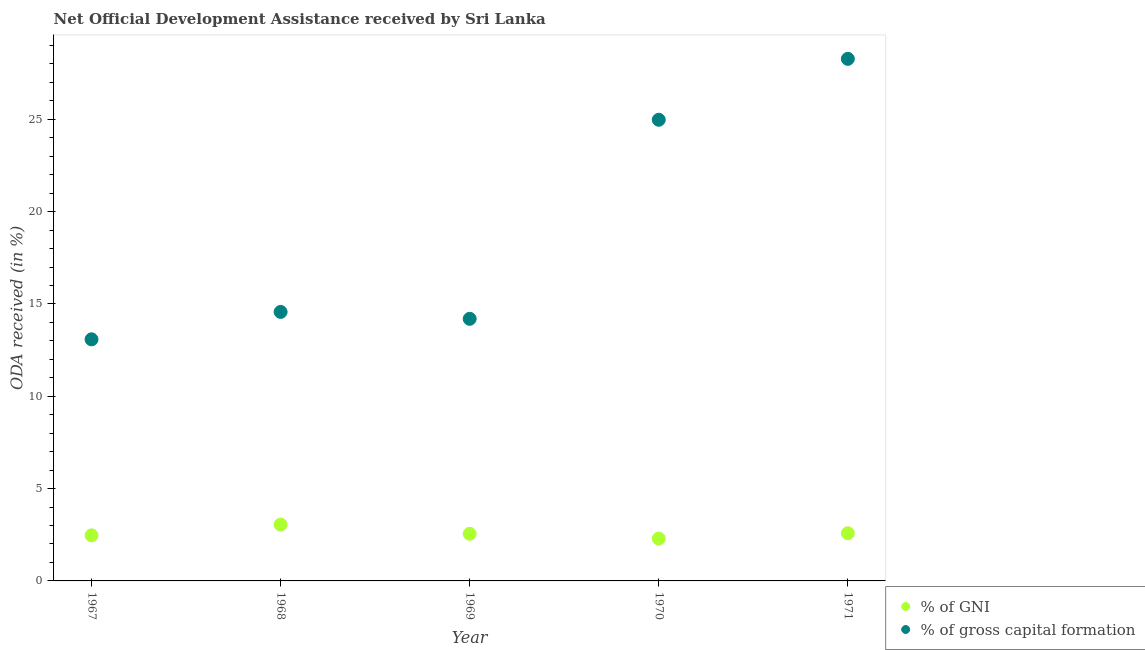How many different coloured dotlines are there?
Provide a succinct answer. 2. What is the oda received as percentage of gni in 1967?
Your answer should be compact. 2.47. Across all years, what is the maximum oda received as percentage of gross capital formation?
Provide a short and direct response. 28.28. Across all years, what is the minimum oda received as percentage of gni?
Give a very brief answer. 2.29. In which year was the oda received as percentage of gross capital formation maximum?
Provide a succinct answer. 1971. In which year was the oda received as percentage of gni minimum?
Provide a short and direct response. 1970. What is the total oda received as percentage of gni in the graph?
Offer a terse response. 12.95. What is the difference between the oda received as percentage of gni in 1968 and that in 1969?
Keep it short and to the point. 0.5. What is the difference between the oda received as percentage of gni in 1967 and the oda received as percentage of gross capital formation in 1971?
Give a very brief answer. -25.81. What is the average oda received as percentage of gni per year?
Make the answer very short. 2.59. In the year 1970, what is the difference between the oda received as percentage of gni and oda received as percentage of gross capital formation?
Keep it short and to the point. -22.68. What is the ratio of the oda received as percentage of gni in 1969 to that in 1970?
Provide a short and direct response. 1.11. Is the oda received as percentage of gross capital formation in 1967 less than that in 1969?
Ensure brevity in your answer.  Yes. What is the difference between the highest and the second highest oda received as percentage of gross capital formation?
Provide a short and direct response. 3.3. What is the difference between the highest and the lowest oda received as percentage of gni?
Your answer should be compact. 0.76. In how many years, is the oda received as percentage of gni greater than the average oda received as percentage of gni taken over all years?
Your answer should be very brief. 1. Is the sum of the oda received as percentage of gni in 1968 and 1971 greater than the maximum oda received as percentage of gross capital formation across all years?
Provide a succinct answer. No. Does the oda received as percentage of gni monotonically increase over the years?
Your answer should be very brief. No. Is the oda received as percentage of gross capital formation strictly greater than the oda received as percentage of gni over the years?
Your response must be concise. Yes. How many years are there in the graph?
Offer a terse response. 5. What is the difference between two consecutive major ticks on the Y-axis?
Offer a very short reply. 5. Are the values on the major ticks of Y-axis written in scientific E-notation?
Your answer should be very brief. No. How are the legend labels stacked?
Make the answer very short. Vertical. What is the title of the graph?
Ensure brevity in your answer.  Net Official Development Assistance received by Sri Lanka. What is the label or title of the Y-axis?
Offer a terse response. ODA received (in %). What is the ODA received (in %) of % of GNI in 1967?
Provide a short and direct response. 2.47. What is the ODA received (in %) of % of gross capital formation in 1967?
Ensure brevity in your answer.  13.09. What is the ODA received (in %) of % of GNI in 1968?
Make the answer very short. 3.05. What is the ODA received (in %) in % of gross capital formation in 1968?
Offer a very short reply. 14.57. What is the ODA received (in %) of % of GNI in 1969?
Give a very brief answer. 2.55. What is the ODA received (in %) in % of gross capital formation in 1969?
Make the answer very short. 14.2. What is the ODA received (in %) in % of GNI in 1970?
Give a very brief answer. 2.29. What is the ODA received (in %) of % of gross capital formation in 1970?
Offer a very short reply. 24.98. What is the ODA received (in %) of % of GNI in 1971?
Offer a terse response. 2.58. What is the ODA received (in %) of % of gross capital formation in 1971?
Your response must be concise. 28.28. Across all years, what is the maximum ODA received (in %) in % of GNI?
Offer a terse response. 3.05. Across all years, what is the maximum ODA received (in %) in % of gross capital formation?
Ensure brevity in your answer.  28.28. Across all years, what is the minimum ODA received (in %) in % of GNI?
Provide a short and direct response. 2.29. Across all years, what is the minimum ODA received (in %) in % of gross capital formation?
Give a very brief answer. 13.09. What is the total ODA received (in %) in % of GNI in the graph?
Your response must be concise. 12.95. What is the total ODA received (in %) in % of gross capital formation in the graph?
Provide a succinct answer. 95.1. What is the difference between the ODA received (in %) in % of GNI in 1967 and that in 1968?
Your answer should be compact. -0.58. What is the difference between the ODA received (in %) of % of gross capital formation in 1967 and that in 1968?
Give a very brief answer. -1.48. What is the difference between the ODA received (in %) in % of GNI in 1967 and that in 1969?
Provide a short and direct response. -0.08. What is the difference between the ODA received (in %) of % of gross capital formation in 1967 and that in 1969?
Ensure brevity in your answer.  -1.11. What is the difference between the ODA received (in %) in % of GNI in 1967 and that in 1970?
Your answer should be very brief. 0.17. What is the difference between the ODA received (in %) of % of gross capital formation in 1967 and that in 1970?
Keep it short and to the point. -11.89. What is the difference between the ODA received (in %) of % of GNI in 1967 and that in 1971?
Provide a short and direct response. -0.11. What is the difference between the ODA received (in %) in % of gross capital formation in 1967 and that in 1971?
Offer a terse response. -15.19. What is the difference between the ODA received (in %) in % of GNI in 1968 and that in 1969?
Provide a short and direct response. 0.5. What is the difference between the ODA received (in %) in % of gross capital formation in 1968 and that in 1969?
Your answer should be compact. 0.37. What is the difference between the ODA received (in %) in % of GNI in 1968 and that in 1970?
Make the answer very short. 0.76. What is the difference between the ODA received (in %) in % of gross capital formation in 1968 and that in 1970?
Your answer should be very brief. -10.41. What is the difference between the ODA received (in %) in % of GNI in 1968 and that in 1971?
Offer a very short reply. 0.47. What is the difference between the ODA received (in %) in % of gross capital formation in 1968 and that in 1971?
Keep it short and to the point. -13.71. What is the difference between the ODA received (in %) of % of GNI in 1969 and that in 1970?
Ensure brevity in your answer.  0.26. What is the difference between the ODA received (in %) in % of gross capital formation in 1969 and that in 1970?
Offer a very short reply. -10.78. What is the difference between the ODA received (in %) of % of GNI in 1969 and that in 1971?
Your answer should be compact. -0.03. What is the difference between the ODA received (in %) of % of gross capital formation in 1969 and that in 1971?
Offer a very short reply. -14.08. What is the difference between the ODA received (in %) of % of GNI in 1970 and that in 1971?
Your answer should be compact. -0.29. What is the difference between the ODA received (in %) of % of gross capital formation in 1970 and that in 1971?
Your response must be concise. -3.3. What is the difference between the ODA received (in %) of % of GNI in 1967 and the ODA received (in %) of % of gross capital formation in 1968?
Keep it short and to the point. -12.1. What is the difference between the ODA received (in %) in % of GNI in 1967 and the ODA received (in %) in % of gross capital formation in 1969?
Provide a short and direct response. -11.73. What is the difference between the ODA received (in %) in % of GNI in 1967 and the ODA received (in %) in % of gross capital formation in 1970?
Ensure brevity in your answer.  -22.51. What is the difference between the ODA received (in %) of % of GNI in 1967 and the ODA received (in %) of % of gross capital formation in 1971?
Give a very brief answer. -25.81. What is the difference between the ODA received (in %) of % of GNI in 1968 and the ODA received (in %) of % of gross capital formation in 1969?
Make the answer very short. -11.15. What is the difference between the ODA received (in %) in % of GNI in 1968 and the ODA received (in %) in % of gross capital formation in 1970?
Offer a terse response. -21.93. What is the difference between the ODA received (in %) of % of GNI in 1968 and the ODA received (in %) of % of gross capital formation in 1971?
Your response must be concise. -25.23. What is the difference between the ODA received (in %) of % of GNI in 1969 and the ODA received (in %) of % of gross capital formation in 1970?
Keep it short and to the point. -22.42. What is the difference between the ODA received (in %) of % of GNI in 1969 and the ODA received (in %) of % of gross capital formation in 1971?
Provide a short and direct response. -25.72. What is the difference between the ODA received (in %) in % of GNI in 1970 and the ODA received (in %) in % of gross capital formation in 1971?
Make the answer very short. -25.98. What is the average ODA received (in %) in % of GNI per year?
Provide a short and direct response. 2.59. What is the average ODA received (in %) in % of gross capital formation per year?
Ensure brevity in your answer.  19.02. In the year 1967, what is the difference between the ODA received (in %) of % of GNI and ODA received (in %) of % of gross capital formation?
Provide a short and direct response. -10.62. In the year 1968, what is the difference between the ODA received (in %) of % of GNI and ODA received (in %) of % of gross capital formation?
Give a very brief answer. -11.52. In the year 1969, what is the difference between the ODA received (in %) of % of GNI and ODA received (in %) of % of gross capital formation?
Your answer should be compact. -11.64. In the year 1970, what is the difference between the ODA received (in %) of % of GNI and ODA received (in %) of % of gross capital formation?
Keep it short and to the point. -22.68. In the year 1971, what is the difference between the ODA received (in %) in % of GNI and ODA received (in %) in % of gross capital formation?
Your answer should be very brief. -25.69. What is the ratio of the ODA received (in %) in % of GNI in 1967 to that in 1968?
Offer a very short reply. 0.81. What is the ratio of the ODA received (in %) of % of gross capital formation in 1967 to that in 1968?
Make the answer very short. 0.9. What is the ratio of the ODA received (in %) in % of GNI in 1967 to that in 1969?
Your response must be concise. 0.97. What is the ratio of the ODA received (in %) of % of gross capital formation in 1967 to that in 1969?
Give a very brief answer. 0.92. What is the ratio of the ODA received (in %) of % of GNI in 1967 to that in 1970?
Your answer should be compact. 1.08. What is the ratio of the ODA received (in %) in % of gross capital formation in 1967 to that in 1970?
Provide a short and direct response. 0.52. What is the ratio of the ODA received (in %) of % of GNI in 1967 to that in 1971?
Give a very brief answer. 0.96. What is the ratio of the ODA received (in %) in % of gross capital formation in 1967 to that in 1971?
Provide a succinct answer. 0.46. What is the ratio of the ODA received (in %) in % of GNI in 1968 to that in 1969?
Provide a short and direct response. 1.2. What is the ratio of the ODA received (in %) in % of gross capital formation in 1968 to that in 1969?
Give a very brief answer. 1.03. What is the ratio of the ODA received (in %) in % of GNI in 1968 to that in 1970?
Provide a short and direct response. 1.33. What is the ratio of the ODA received (in %) of % of gross capital formation in 1968 to that in 1970?
Offer a terse response. 0.58. What is the ratio of the ODA received (in %) of % of GNI in 1968 to that in 1971?
Ensure brevity in your answer.  1.18. What is the ratio of the ODA received (in %) of % of gross capital formation in 1968 to that in 1971?
Make the answer very short. 0.52. What is the ratio of the ODA received (in %) in % of GNI in 1969 to that in 1970?
Keep it short and to the point. 1.11. What is the ratio of the ODA received (in %) in % of gross capital formation in 1969 to that in 1970?
Provide a short and direct response. 0.57. What is the ratio of the ODA received (in %) in % of GNI in 1969 to that in 1971?
Make the answer very short. 0.99. What is the ratio of the ODA received (in %) of % of gross capital formation in 1969 to that in 1971?
Provide a succinct answer. 0.5. What is the ratio of the ODA received (in %) of % of GNI in 1970 to that in 1971?
Ensure brevity in your answer.  0.89. What is the ratio of the ODA received (in %) of % of gross capital formation in 1970 to that in 1971?
Provide a succinct answer. 0.88. What is the difference between the highest and the second highest ODA received (in %) of % of GNI?
Provide a succinct answer. 0.47. What is the difference between the highest and the second highest ODA received (in %) in % of gross capital formation?
Keep it short and to the point. 3.3. What is the difference between the highest and the lowest ODA received (in %) in % of GNI?
Your answer should be compact. 0.76. What is the difference between the highest and the lowest ODA received (in %) of % of gross capital formation?
Provide a short and direct response. 15.19. 